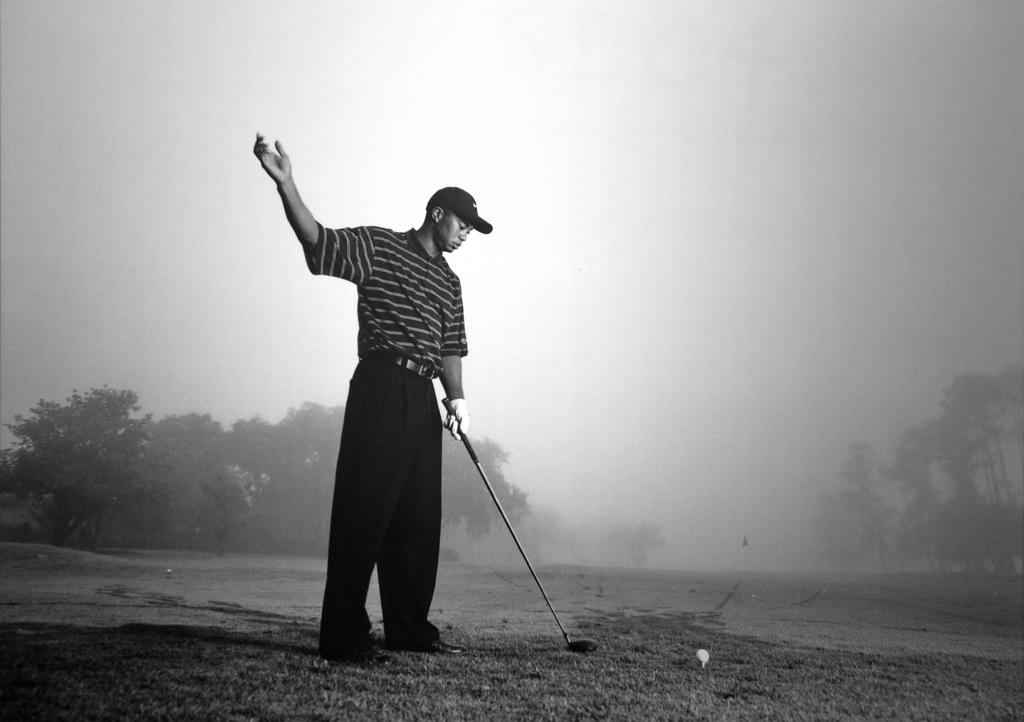What is the man in the image doing? The man is standing in the image and holding a stick. What object is the man holding in the image? The man is holding a stick. What other objects can be seen in the image? There is a ball visible in the image. What type of environment is depicted in the image? The image shows grass, trees, and the sky in the background, suggesting an outdoor setting. What type of metal is used to make the stove in the image? There is no stove present in the image; it features a man holding a stick, a ball, and an outdoor setting. 